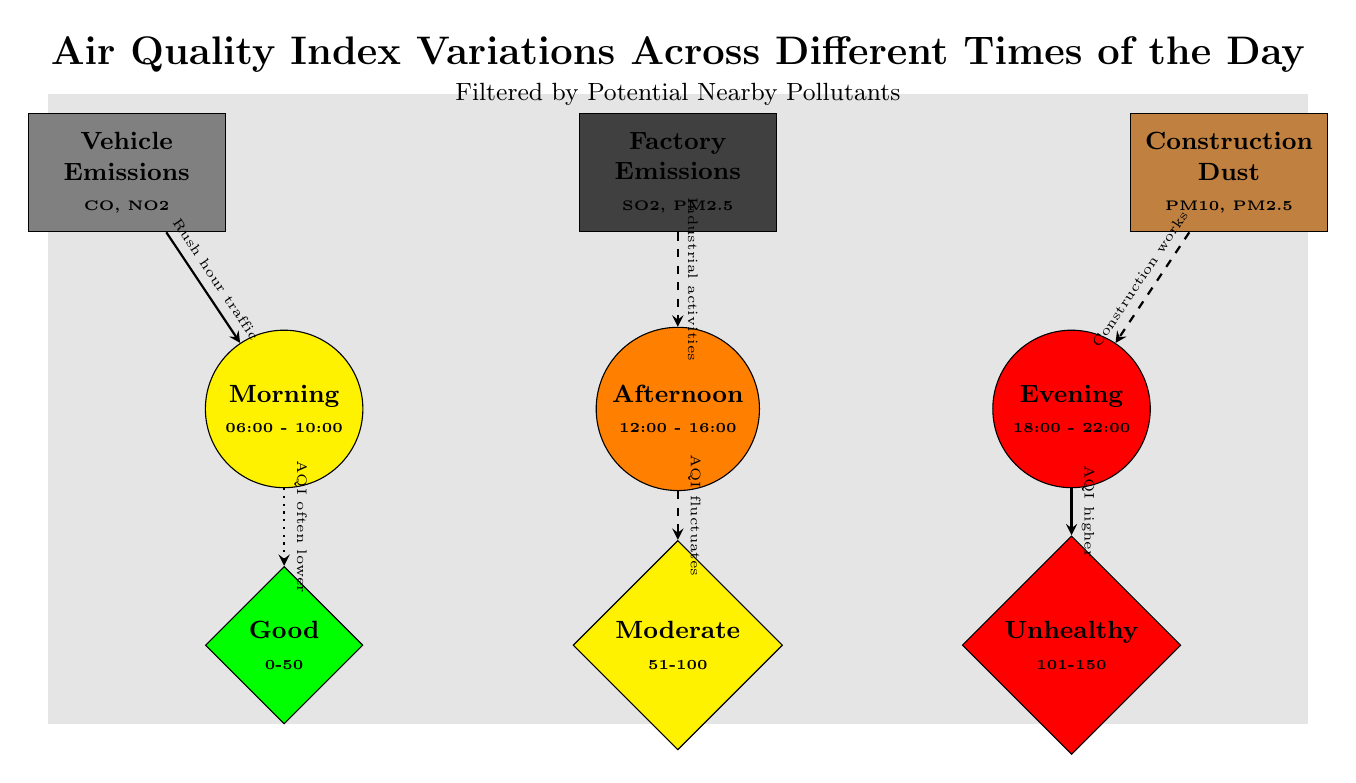What is the Air Quality Index level in the morning? The morning node is connected to the 'Good' AQI node. According to the diagram, the 'Good' AQI is defined as a range from 0 to 50, indicating that the air quality is often lower during this time.
Answer: Good Which time period has an unhealthy Air Quality Index? The evening node is connected to the 'Unhealthy' AQI node. The 'Unhealthy' AQI is defined in the range of 101 to 150, indicating poorer air quality during this specific time period.
Answer: Evening What causes fluctuating AQI during the afternoon? The afternoon node is connected to the factory emissions node. The diagram states that industrial activities are responsible for this fluctuation, indicating that nearby factories contribute to the afternoon AQI variable.
Answer: Industrial activities How many time periods are shown in the diagram? There are three distinct time nodes illustrated: morning, afternoon, and evening, signifying three time periods throughout the day.
Answer: 3 Which pollutant is associated with the highest AQI? The evening is linked to construction dust, which correlates with an 'Unhealthy' AQI level indicating the highest pollution levels at that time.
Answer: Construction Dust What type of relationship is indicated between vehicle emissions and the morning AQI? The relationship shown between vehicle emissions and the morning AQI is a solid line, indicating a direct connection. The diagram describes this connection as responsible for lower AQI during rush hour traffic in the morning.
Answer: Direct connection What color represents the 'Moderate' Air Quality Index in the diagram? The 'Moderate' AQI node is represented by the color yellow in the diagram, which corresponds to AQI values ranging from 51 to 100.
Answer: Yellow Which time period is linked to construction works? The evening node is connected to construction dust, with a dashed line indicating that construction activities affect air quality during this time.
Answer: Evening What does a dotted edge signify in the diagram? The dotted edge between the morning and 'Good' AQI signifies that the air quality is often lower during that time, representing a less definite connection compared to solid or dashed lines.
Answer: Often lower 